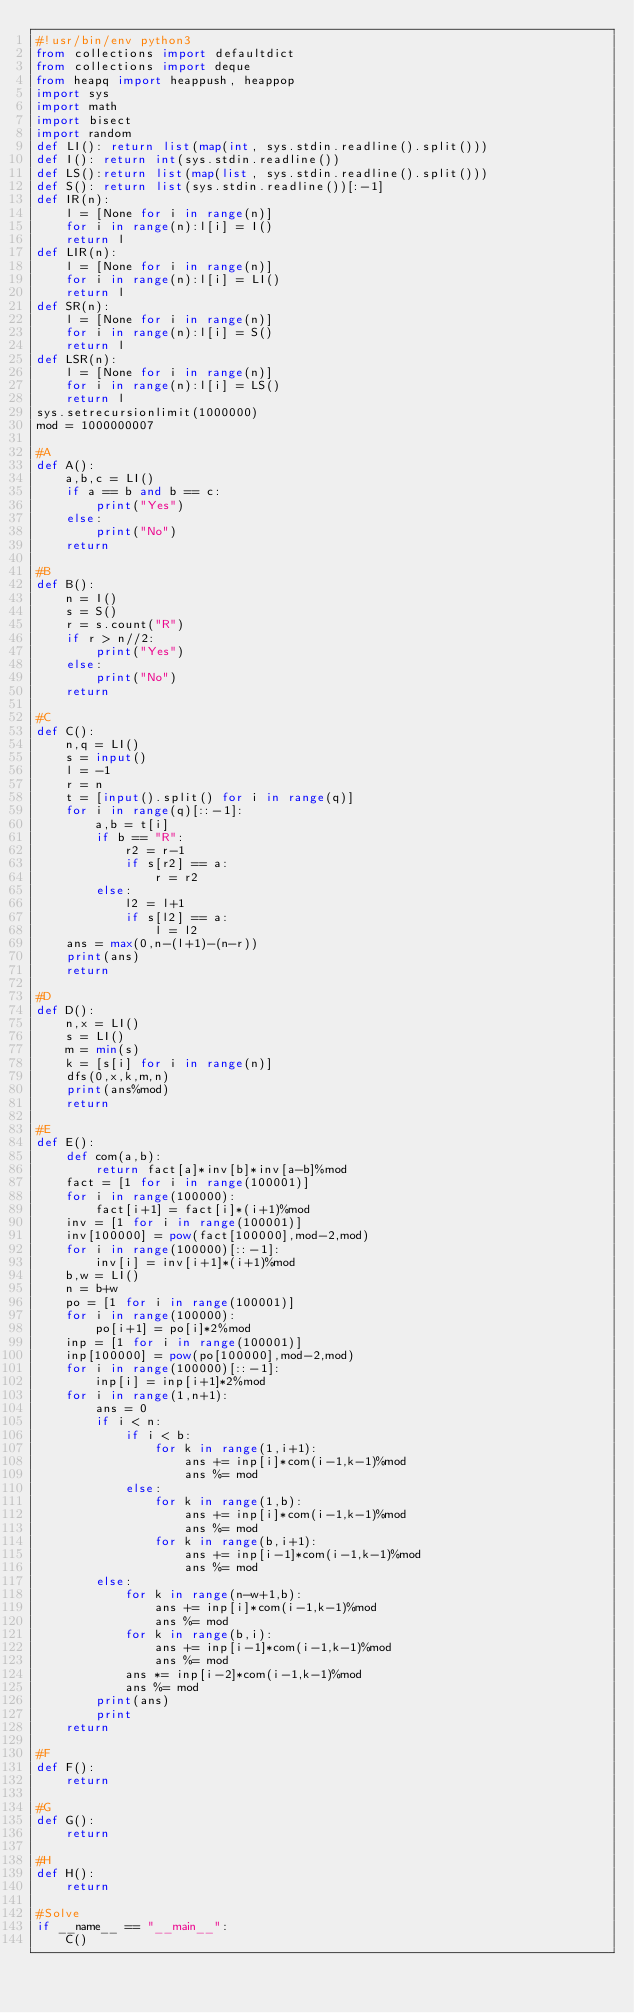<code> <loc_0><loc_0><loc_500><loc_500><_Python_>#!usr/bin/env python3
from collections import defaultdict
from collections import deque
from heapq import heappush, heappop
import sys
import math
import bisect
import random
def LI(): return list(map(int, sys.stdin.readline().split()))
def I(): return int(sys.stdin.readline())
def LS():return list(map(list, sys.stdin.readline().split()))
def S(): return list(sys.stdin.readline())[:-1]
def IR(n):
    l = [None for i in range(n)]
    for i in range(n):l[i] = I()
    return l
def LIR(n):
    l = [None for i in range(n)]
    for i in range(n):l[i] = LI()
    return l
def SR(n):
    l = [None for i in range(n)]
    for i in range(n):l[i] = S()
    return l
def LSR(n):
    l = [None for i in range(n)]
    for i in range(n):l[i] = LS()
    return l
sys.setrecursionlimit(1000000)
mod = 1000000007

#A
def A():
    a,b,c = LI()
    if a == b and b == c:
        print("Yes")
    else:
        print("No")
    return

#B
def B():
    n = I()
    s = S()
    r = s.count("R")
    if r > n//2:
        print("Yes")
    else:
        print("No")
    return

#C
def C():
    n,q = LI()
    s = input()
    l = -1
    r = n
    t = [input().split() for i in range(q)]
    for i in range(q)[::-1]:
        a,b = t[i]
        if b == "R":
            r2 = r-1
            if s[r2] == a:
                r = r2
        else:
            l2 = l+1
            if s[l2] == a:
                l = l2
    ans = max(0,n-(l+1)-(n-r))
    print(ans)
    return

#D
def D():
    n,x = LI()
    s = LI()
    m = min(s)
    k = [s[i] for i in range(n)]
    dfs(0,x,k,m,n)
    print(ans%mod)
    return

#E
def E():
    def com(a,b):
        return fact[a]*inv[b]*inv[a-b]%mod
    fact = [1 for i in range(100001)]
    for i in range(100000):
        fact[i+1] = fact[i]*(i+1)%mod
    inv = [1 for i in range(100001)]
    inv[100000] = pow(fact[100000],mod-2,mod)
    for i in range(100000)[::-1]:
        inv[i] = inv[i+1]*(i+1)%mod
    b,w = LI()
    n = b+w
    po = [1 for i in range(100001)]
    for i in range(100000):
        po[i+1] = po[i]*2%mod
    inp = [1 for i in range(100001)]
    inp[100000] = pow(po[100000],mod-2,mod)
    for i in range(100000)[::-1]:
        inp[i] = inp[i+1]*2%mod
    for i in range(1,n+1):
        ans = 0
        if i < n:
            if i < b:
                for k in range(1,i+1):
                    ans += inp[i]*com(i-1,k-1)%mod
                    ans %= mod
            else:
                for k in range(1,b):
                    ans += inp[i]*com(i-1,k-1)%mod
                    ans %= mod
                for k in range(b,i+1):
                    ans += inp[i-1]*com(i-1,k-1)%mod
                    ans %= mod
        else:
            for k in range(n-w+1,b):
                ans += inp[i]*com(i-1,k-1)%mod
                ans %= mod
            for k in range(b,i):
                ans += inp[i-1]*com(i-1,k-1)%mod
                ans %= mod
            ans *= inp[i-2]*com(i-1,k-1)%mod
            ans %= mod
        print(ans)
        print
    return

#F
def F():
    return

#G
def G():
    return

#H
def H():
    return

#Solve
if __name__ == "__main__":
    C()
</code> 